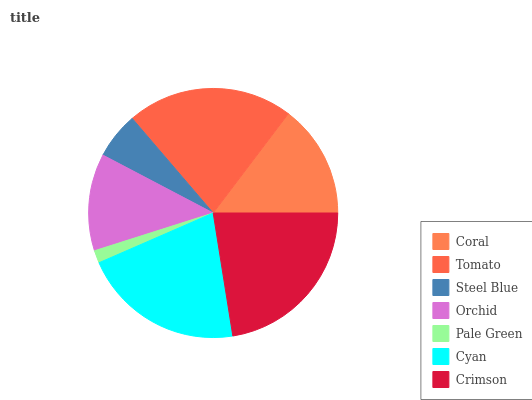Is Pale Green the minimum?
Answer yes or no. Yes. Is Crimson the maximum?
Answer yes or no. Yes. Is Tomato the minimum?
Answer yes or no. No. Is Tomato the maximum?
Answer yes or no. No. Is Tomato greater than Coral?
Answer yes or no. Yes. Is Coral less than Tomato?
Answer yes or no. Yes. Is Coral greater than Tomato?
Answer yes or no. No. Is Tomato less than Coral?
Answer yes or no. No. Is Coral the high median?
Answer yes or no. Yes. Is Coral the low median?
Answer yes or no. Yes. Is Tomato the high median?
Answer yes or no. No. Is Tomato the low median?
Answer yes or no. No. 